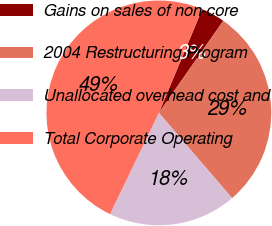Convert chart. <chart><loc_0><loc_0><loc_500><loc_500><pie_chart><fcel>Gains on sales of non-core<fcel>2004 Restructuring Program<fcel>Unallocated overhead cost and<fcel>Total Corporate Operating<nl><fcel>3.41%<fcel>28.99%<fcel>18.45%<fcel>49.15%<nl></chart> 